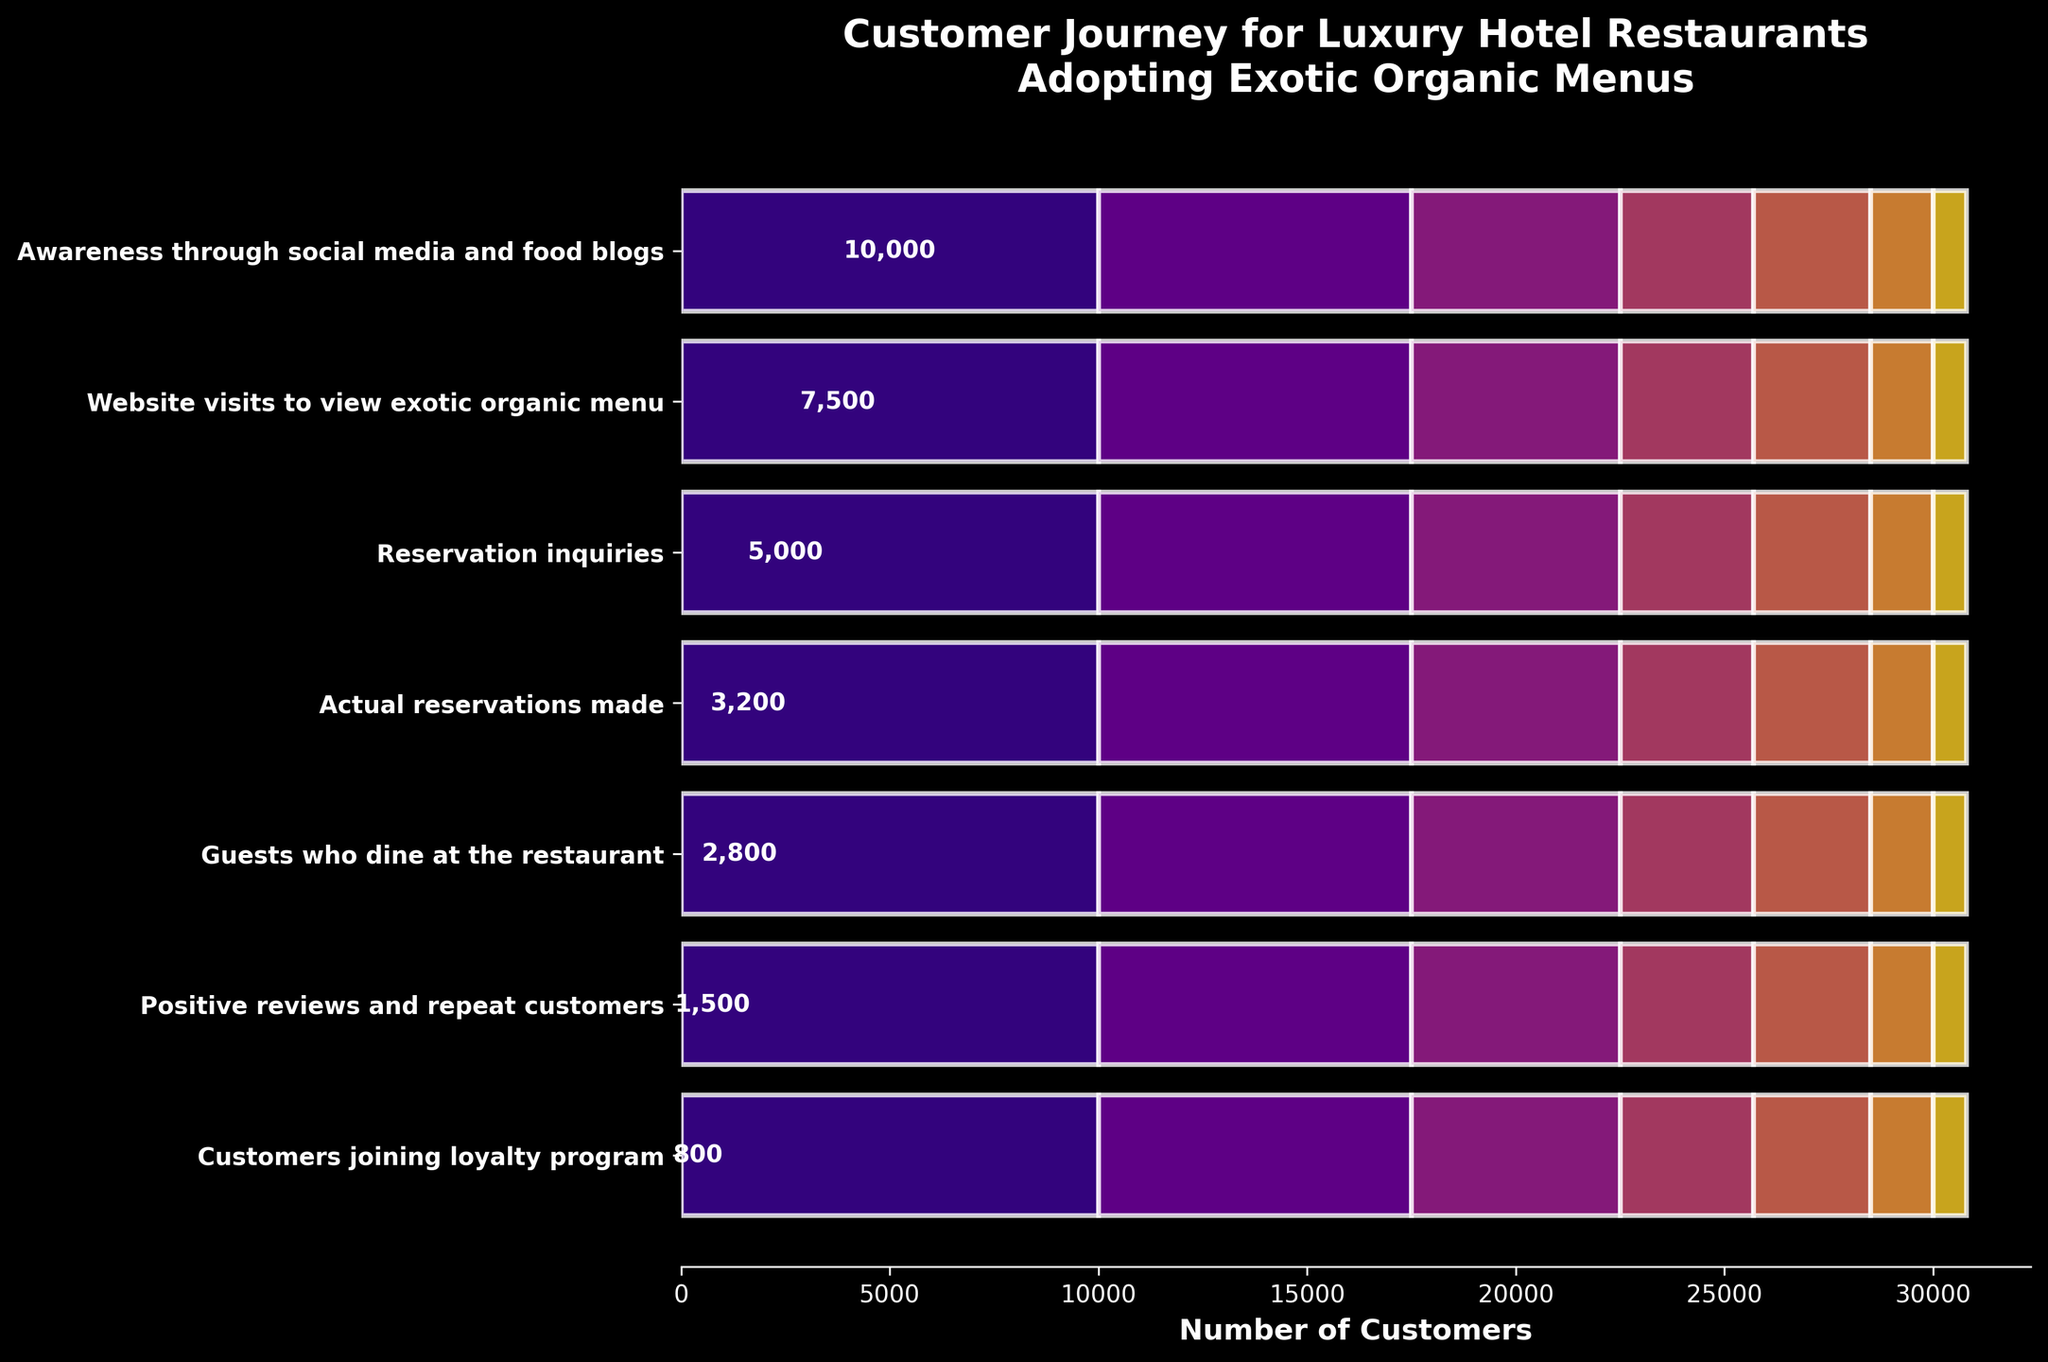What is the title of the funnel chart? The title of the funnel chart is typically displayed at the top of the chart. Here, it is given as "Customer Journey for Luxury Hotel Restaurants Adopting Exotic Organic Menus."
Answer: Customer Journey for Luxury Hotel Restaurants Adopting Exotic Organic Menus Which stage has the highest number of customers? To identify the stage with the highest number of customers, look at the bar with the maximum length. The "Awareness through social media and food blogs" stage has the longest bar, indicating the highest customer count.
Answer: Awareness through social media and food blogs What are the end stages of the funnel? The end stages are the ones at the bottom of the funnel where customer counts are the lowest. Here, they are "Guests who dine at the restaurant," "Positive reviews and repeat customers," and "Customers joining loyalty program."
Answer: Guests who dine at the restaurant, Positive reviews and repeat customers, Customers joining loyalty program How many customers make actual reservations? Look at the corresponding bar labeled "Actual reservations made" to find the number of customers. The number shown within this bar is 3200.
Answer: 3200 How many customers are gained between reservation inquiries and actual reservations made? Subtract the number of customers who made actual reservations from those who inquired about reservations. That is, 5000 (reservation inquiries) - 3200 (actual reservations) = 1800.
Answer: 1800 What’s the percentage drop from website visits to dining at the restaurant? Calculate using the formula (initial - final) / initial * 100. That’s (7500 - 2800) / 7500 * 100 = 62.67%.
Answer: 62.67% Which stage witnesses the most significant decline in customer numbers? Compare the differences between successive stages. The largest decline happens between "Reservation inquiries" (5000) and "Actual reservations made" (3200). The drop is 1800 which is greater than drops in other stages.
Answer: Reservation inquiries to Actual reservations made What percentage of customers who visit the website also make a reservation? Divide the number of reservations by the number of website visits and multiply by 100. That’s (3200 / 7500) * 100 = 42.67%.
Answer: 42.67% At which stage do customer numbers more than halve? Identify the stage where customers drop to less than half of the previous stage. From "Guests who dine at the restaurant" (2800) to "Positive reviews and repeat customers" (1500), the drop is more than half.
Answer: Positive reviews and repeat customers What is the average number of customers across all stages? Sum the number of customers in all stages and divide by the number of stages. That’s (10000 + 7500 + 5000 + 3200 + 2800 + 1500 + 800) / 7 = 5357.14.
Answer: 5357.14 